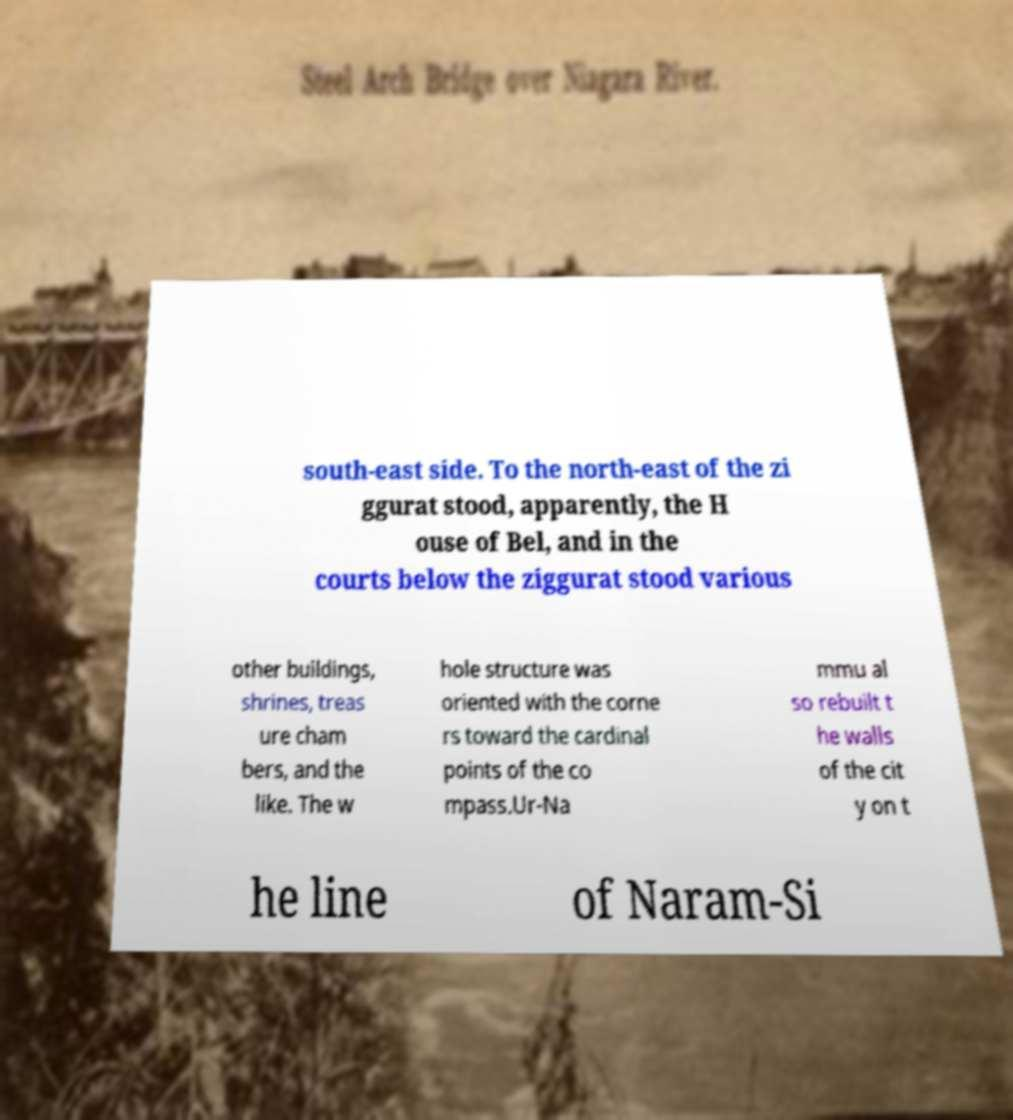Could you assist in decoding the text presented in this image and type it out clearly? south-east side. To the north-east of the zi ggurat stood, apparently, the H ouse of Bel, and in the courts below the ziggurat stood various other buildings, shrines, treas ure cham bers, and the like. The w hole structure was oriented with the corne rs toward the cardinal points of the co mpass.Ur-Na mmu al so rebuilt t he walls of the cit y on t he line of Naram-Si 